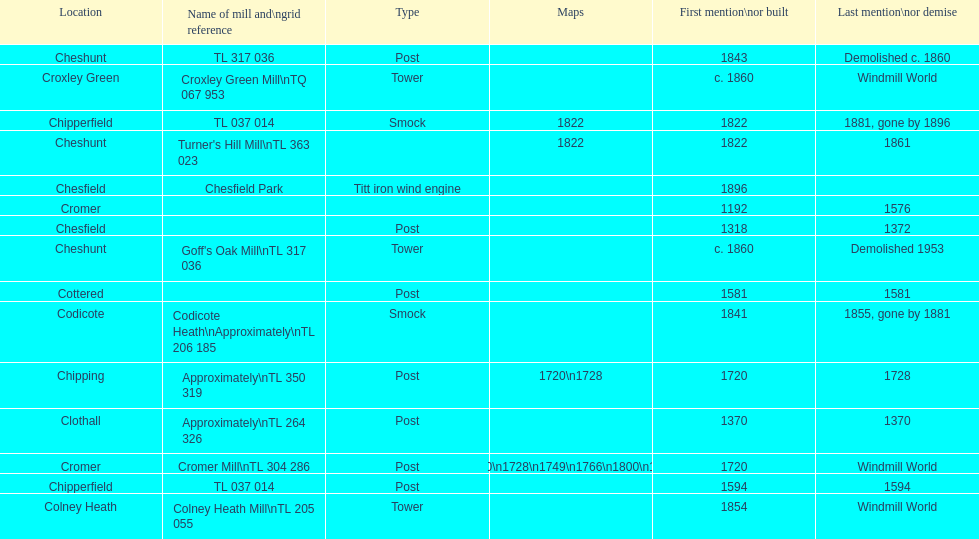What is the total number of mills named cheshunt? 3. 